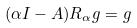<formula> <loc_0><loc_0><loc_500><loc_500>( \alpha I - A ) R _ { \alpha } g = g</formula> 